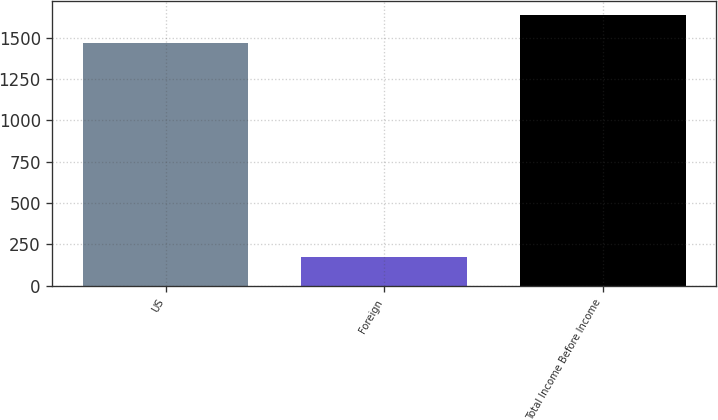<chart> <loc_0><loc_0><loc_500><loc_500><bar_chart><fcel>US<fcel>Foreign<fcel>Total Income Before Income<nl><fcel>1466<fcel>172<fcel>1638<nl></chart> 